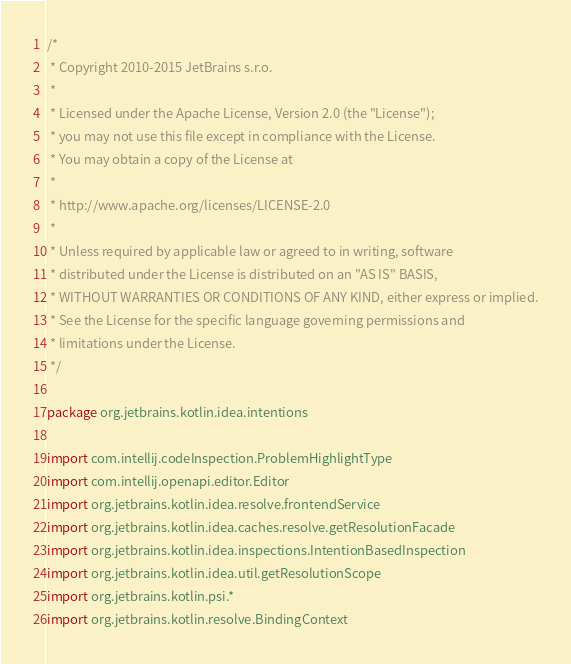<code> <loc_0><loc_0><loc_500><loc_500><_Kotlin_>/*
 * Copyright 2010-2015 JetBrains s.r.o.
 *
 * Licensed under the Apache License, Version 2.0 (the "License");
 * you may not use this file except in compliance with the License.
 * You may obtain a copy of the License at
 *
 * http://www.apache.org/licenses/LICENSE-2.0
 *
 * Unless required by applicable law or agreed to in writing, software
 * distributed under the License is distributed on an "AS IS" BASIS,
 * WITHOUT WARRANTIES OR CONDITIONS OF ANY KIND, either express or implied.
 * See the License for the specific language governing permissions and
 * limitations under the License.
 */

package org.jetbrains.kotlin.idea.intentions

import com.intellij.codeInspection.ProblemHighlightType
import com.intellij.openapi.editor.Editor
import org.jetbrains.kotlin.idea.resolve.frontendService
import org.jetbrains.kotlin.idea.caches.resolve.getResolutionFacade
import org.jetbrains.kotlin.idea.inspections.IntentionBasedInspection
import org.jetbrains.kotlin.idea.util.getResolutionScope
import org.jetbrains.kotlin.psi.*
import org.jetbrains.kotlin.resolve.BindingContext</code> 